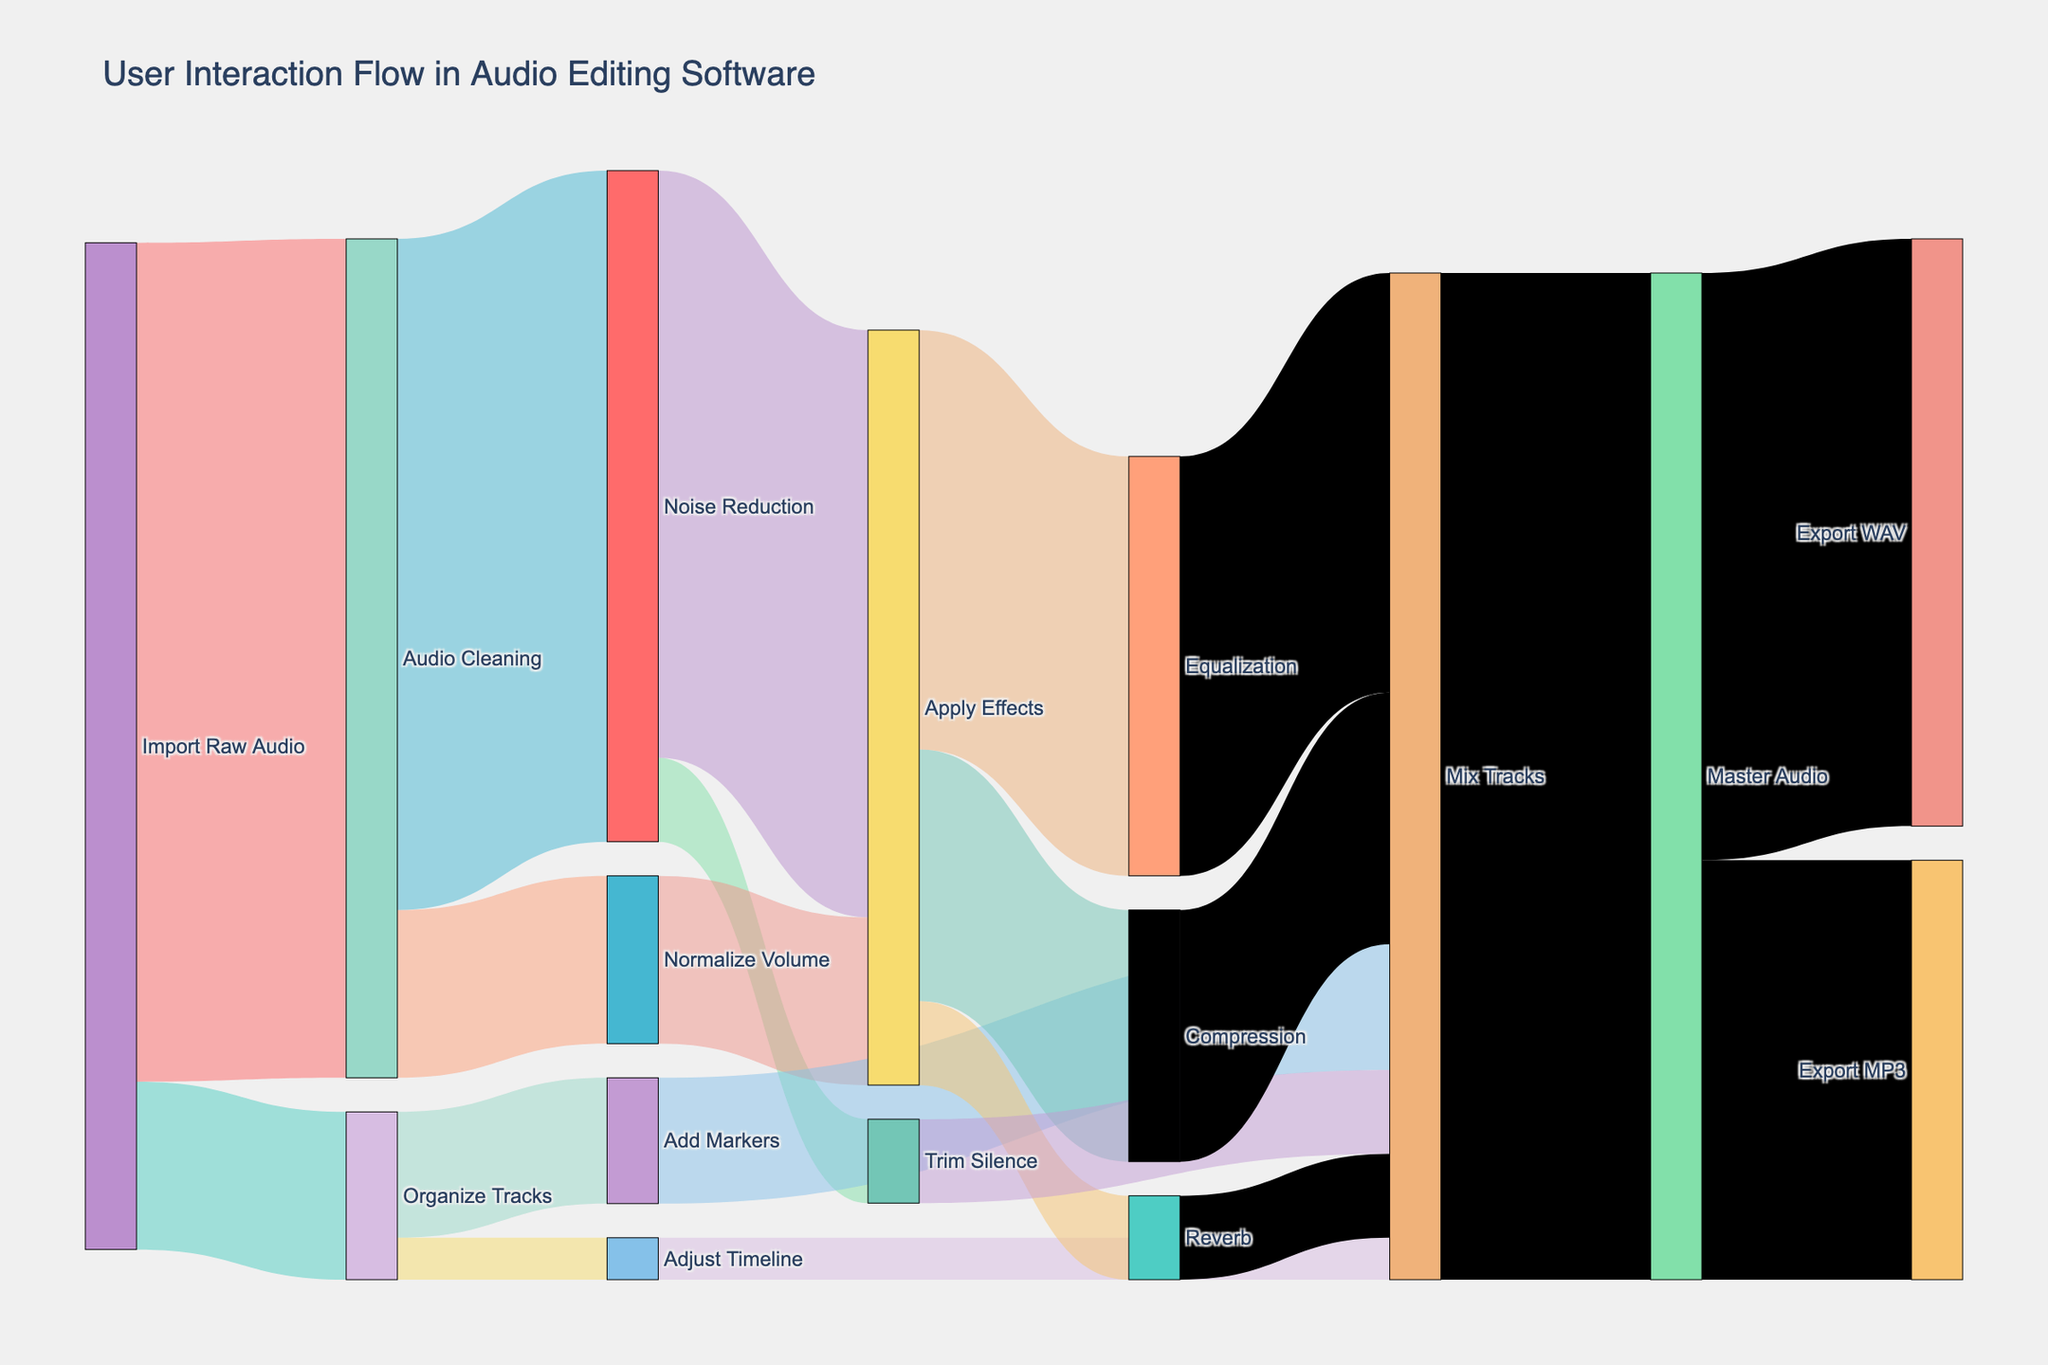What is the title of the Sankey diagram? Look at the top of the diagram where the title is displayed.
Answer: User Interaction Flow in Audio Editing Software What node do the majority of tasks flow from initially? Identify the node with the highest number of connections leading from it at the starting point of the process. The initial node should have the highest sum of values for its outgoing links.
Answer: Import Raw Audio How many users proceed to 'Apply Effects' from 'Noise Reduction'? Check the connection between 'Noise Reduction' and 'Apply Effects' and note the value assigned to it.
Answer: 70 How does the traffic split between 'Export WAV' and 'Export MP3'? Look at the values of the connections leading from the 'Master Audio' node to 'Export WAV' and 'Export MP3'. Compare these values.
Answer: 70 for WAV, 50 for MP3 What is the total number of users that move on to 'Mix Tracks'? Sum the values of all connections leading to 'Mix Tracks' from different steps.
Answer: 50 (Equalization) + 30 (Compression) + 15 (Add Markers) + 10 (Reverb) + 10 (Trim Silence) + 5 (Adjust Timeline) = 120 Which step has the least number of users moving from 'Organize Tracks'? Identify the outgoing links from 'Organize Tracks' and compare their values. The link with the smallest value is the answer.
Answer: Adjust Timeline What percentage of users import raw audio for 'Organize Tracks'? Divide the number of users moving to 'Organize Tracks' from 'Import Raw Audio' by the total users importing raw audio and multiply by 100 to get the percentage.
Answer: (20 / (100 + 20)) * 100 ≈ 16.67% Which step has more users, 'Noise Reduction' or 'Normalize Volume'? Compare the values of the connections going from 'Audio Cleaning' to 'Noise Reduction' and 'Normalize Volume'.
Answer: Noise Reduction How many users proceed from 'Apply Effects' to 'Equalization' compared to 'Compression'? Look at the values of the connections between 'Apply Effects' and 'Equalization' and between 'Apply Effects' and 'Compression'.
Answer: 50 for Equalization, 30 for Compression What is the final step for users before exporting the audio file? Follow the flow from the nodes to identify the step linked to the 'Export WAV' and 'Export MP3' nodes.
Answer: Master Audio 